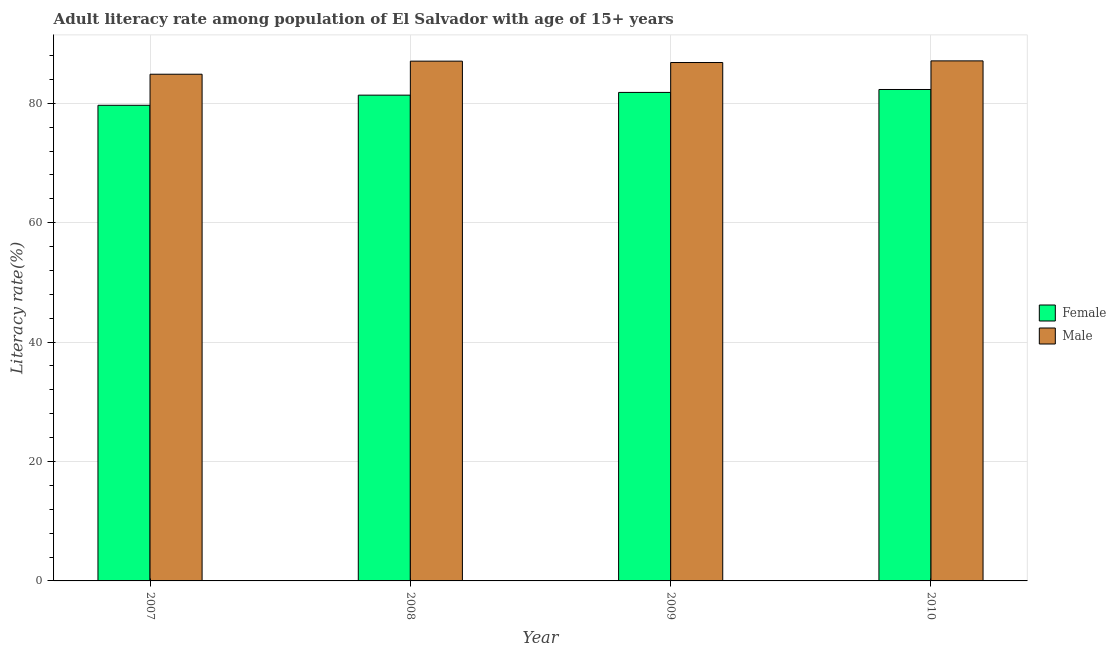How many different coloured bars are there?
Offer a terse response. 2. How many bars are there on the 4th tick from the left?
Your answer should be compact. 2. What is the label of the 3rd group of bars from the left?
Ensure brevity in your answer.  2009. What is the male adult literacy rate in 2009?
Your answer should be very brief. 86.83. Across all years, what is the maximum male adult literacy rate?
Your answer should be very brief. 87.1. Across all years, what is the minimum female adult literacy rate?
Provide a short and direct response. 79.66. In which year was the male adult literacy rate minimum?
Provide a short and direct response. 2007. What is the total female adult literacy rate in the graph?
Ensure brevity in your answer.  325.15. What is the difference between the female adult literacy rate in 2007 and that in 2010?
Offer a very short reply. -2.65. What is the difference between the male adult literacy rate in 2008 and the female adult literacy rate in 2007?
Provide a succinct answer. 2.19. What is the average male adult literacy rate per year?
Give a very brief answer. 86.46. In the year 2009, what is the difference between the male adult literacy rate and female adult literacy rate?
Offer a terse response. 0. In how many years, is the female adult literacy rate greater than 4 %?
Provide a short and direct response. 4. What is the ratio of the male adult literacy rate in 2009 to that in 2010?
Keep it short and to the point. 1. Is the female adult literacy rate in 2007 less than that in 2009?
Offer a terse response. Yes. Is the difference between the male adult literacy rate in 2007 and 2009 greater than the difference between the female adult literacy rate in 2007 and 2009?
Your answer should be very brief. No. What is the difference between the highest and the second highest female adult literacy rate?
Offer a terse response. 0.49. What is the difference between the highest and the lowest male adult literacy rate?
Make the answer very short. 2.24. Is the sum of the female adult literacy rate in 2008 and 2010 greater than the maximum male adult literacy rate across all years?
Offer a terse response. Yes. How many years are there in the graph?
Offer a terse response. 4. Are the values on the major ticks of Y-axis written in scientific E-notation?
Your response must be concise. No. Does the graph contain grids?
Keep it short and to the point. Yes. Where does the legend appear in the graph?
Your answer should be very brief. Center right. What is the title of the graph?
Make the answer very short. Adult literacy rate among population of El Salvador with age of 15+ years. Does "Investments" appear as one of the legend labels in the graph?
Offer a very short reply. No. What is the label or title of the Y-axis?
Your answer should be very brief. Literacy rate(%). What is the Literacy rate(%) in Female in 2007?
Offer a terse response. 79.66. What is the Literacy rate(%) of Male in 2007?
Ensure brevity in your answer.  84.86. What is the Literacy rate(%) of Female in 2008?
Your response must be concise. 81.36. What is the Literacy rate(%) in Male in 2008?
Provide a succinct answer. 87.05. What is the Literacy rate(%) in Female in 2009?
Provide a short and direct response. 81.82. What is the Literacy rate(%) in Male in 2009?
Give a very brief answer. 86.83. What is the Literacy rate(%) in Female in 2010?
Offer a terse response. 82.31. What is the Literacy rate(%) in Male in 2010?
Your answer should be compact. 87.1. Across all years, what is the maximum Literacy rate(%) in Female?
Ensure brevity in your answer.  82.31. Across all years, what is the maximum Literacy rate(%) of Male?
Make the answer very short. 87.1. Across all years, what is the minimum Literacy rate(%) in Female?
Your answer should be very brief. 79.66. Across all years, what is the minimum Literacy rate(%) of Male?
Offer a terse response. 84.86. What is the total Literacy rate(%) of Female in the graph?
Offer a terse response. 325.15. What is the total Literacy rate(%) of Male in the graph?
Keep it short and to the point. 345.84. What is the difference between the Literacy rate(%) of Female in 2007 and that in 2008?
Your answer should be compact. -1.7. What is the difference between the Literacy rate(%) of Male in 2007 and that in 2008?
Provide a short and direct response. -2.19. What is the difference between the Literacy rate(%) of Female in 2007 and that in 2009?
Make the answer very short. -2.16. What is the difference between the Literacy rate(%) of Male in 2007 and that in 2009?
Your response must be concise. -1.96. What is the difference between the Literacy rate(%) in Female in 2007 and that in 2010?
Your response must be concise. -2.65. What is the difference between the Literacy rate(%) of Male in 2007 and that in 2010?
Ensure brevity in your answer.  -2.24. What is the difference between the Literacy rate(%) of Female in 2008 and that in 2009?
Keep it short and to the point. -0.46. What is the difference between the Literacy rate(%) in Male in 2008 and that in 2009?
Make the answer very short. 0.23. What is the difference between the Literacy rate(%) in Female in 2008 and that in 2010?
Make the answer very short. -0.95. What is the difference between the Literacy rate(%) in Male in 2008 and that in 2010?
Offer a very short reply. -0.04. What is the difference between the Literacy rate(%) in Female in 2009 and that in 2010?
Provide a short and direct response. -0.49. What is the difference between the Literacy rate(%) in Male in 2009 and that in 2010?
Keep it short and to the point. -0.27. What is the difference between the Literacy rate(%) in Female in 2007 and the Literacy rate(%) in Male in 2008?
Your response must be concise. -7.39. What is the difference between the Literacy rate(%) in Female in 2007 and the Literacy rate(%) in Male in 2009?
Provide a succinct answer. -7.16. What is the difference between the Literacy rate(%) of Female in 2007 and the Literacy rate(%) of Male in 2010?
Keep it short and to the point. -7.44. What is the difference between the Literacy rate(%) in Female in 2008 and the Literacy rate(%) in Male in 2009?
Ensure brevity in your answer.  -5.47. What is the difference between the Literacy rate(%) of Female in 2008 and the Literacy rate(%) of Male in 2010?
Give a very brief answer. -5.74. What is the difference between the Literacy rate(%) of Female in 2009 and the Literacy rate(%) of Male in 2010?
Provide a succinct answer. -5.28. What is the average Literacy rate(%) of Female per year?
Ensure brevity in your answer.  81.29. What is the average Literacy rate(%) of Male per year?
Your answer should be very brief. 86.46. In the year 2007, what is the difference between the Literacy rate(%) in Female and Literacy rate(%) in Male?
Provide a short and direct response. -5.2. In the year 2008, what is the difference between the Literacy rate(%) of Female and Literacy rate(%) of Male?
Make the answer very short. -5.7. In the year 2009, what is the difference between the Literacy rate(%) in Female and Literacy rate(%) in Male?
Provide a succinct answer. -5.01. In the year 2010, what is the difference between the Literacy rate(%) in Female and Literacy rate(%) in Male?
Your answer should be compact. -4.79. What is the ratio of the Literacy rate(%) in Female in 2007 to that in 2008?
Offer a terse response. 0.98. What is the ratio of the Literacy rate(%) in Male in 2007 to that in 2008?
Make the answer very short. 0.97. What is the ratio of the Literacy rate(%) of Female in 2007 to that in 2009?
Keep it short and to the point. 0.97. What is the ratio of the Literacy rate(%) in Male in 2007 to that in 2009?
Your answer should be very brief. 0.98. What is the ratio of the Literacy rate(%) in Female in 2007 to that in 2010?
Give a very brief answer. 0.97. What is the ratio of the Literacy rate(%) of Male in 2007 to that in 2010?
Offer a very short reply. 0.97. What is the ratio of the Literacy rate(%) in Female in 2008 to that in 2009?
Provide a succinct answer. 0.99. What is the ratio of the Literacy rate(%) in Male in 2008 to that in 2009?
Ensure brevity in your answer.  1. What is the ratio of the Literacy rate(%) in Female in 2008 to that in 2010?
Your answer should be very brief. 0.99. What is the ratio of the Literacy rate(%) in Female in 2009 to that in 2010?
Your answer should be very brief. 0.99. What is the ratio of the Literacy rate(%) in Male in 2009 to that in 2010?
Keep it short and to the point. 1. What is the difference between the highest and the second highest Literacy rate(%) of Female?
Provide a short and direct response. 0.49. What is the difference between the highest and the second highest Literacy rate(%) in Male?
Offer a terse response. 0.04. What is the difference between the highest and the lowest Literacy rate(%) of Female?
Your answer should be compact. 2.65. What is the difference between the highest and the lowest Literacy rate(%) of Male?
Provide a short and direct response. 2.24. 